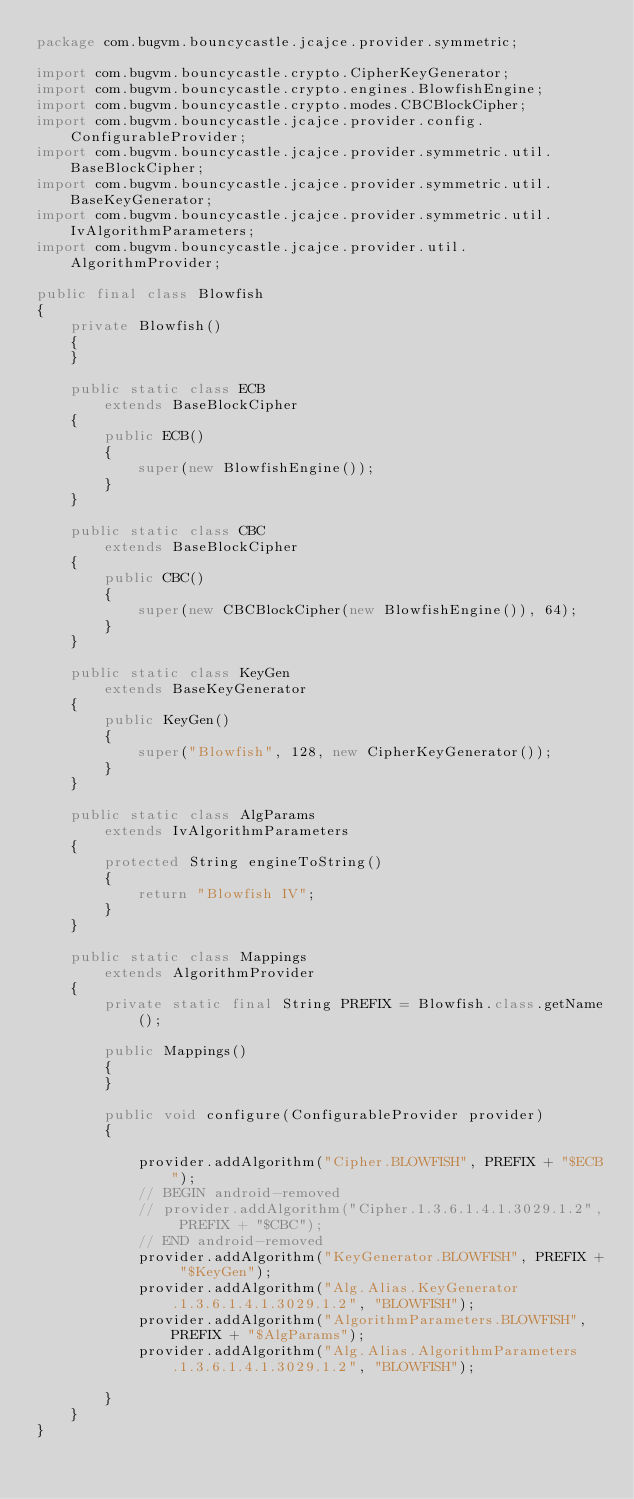Convert code to text. <code><loc_0><loc_0><loc_500><loc_500><_Java_>package com.bugvm.bouncycastle.jcajce.provider.symmetric;

import com.bugvm.bouncycastle.crypto.CipherKeyGenerator;
import com.bugvm.bouncycastle.crypto.engines.BlowfishEngine;
import com.bugvm.bouncycastle.crypto.modes.CBCBlockCipher;
import com.bugvm.bouncycastle.jcajce.provider.config.ConfigurableProvider;
import com.bugvm.bouncycastle.jcajce.provider.symmetric.util.BaseBlockCipher;
import com.bugvm.bouncycastle.jcajce.provider.symmetric.util.BaseKeyGenerator;
import com.bugvm.bouncycastle.jcajce.provider.symmetric.util.IvAlgorithmParameters;
import com.bugvm.bouncycastle.jcajce.provider.util.AlgorithmProvider;

public final class Blowfish
{
    private Blowfish()
    {
    }
    
    public static class ECB
        extends BaseBlockCipher
    {
        public ECB()
        {
            super(new BlowfishEngine());
        }
    }

    public static class CBC
        extends BaseBlockCipher
    {
        public CBC()
        {
            super(new CBCBlockCipher(new BlowfishEngine()), 64);
        }
    }

    public static class KeyGen
        extends BaseKeyGenerator
    {
        public KeyGen()
        {
            super("Blowfish", 128, new CipherKeyGenerator());
        }
    }

    public static class AlgParams
        extends IvAlgorithmParameters
    {
        protected String engineToString()
        {
            return "Blowfish IV";
        }
    }

    public static class Mappings
        extends AlgorithmProvider
    {
        private static final String PREFIX = Blowfish.class.getName();

        public Mappings()
        {
        }

        public void configure(ConfigurableProvider provider)
        {

            provider.addAlgorithm("Cipher.BLOWFISH", PREFIX + "$ECB");
            // BEGIN android-removed
            // provider.addAlgorithm("Cipher.1.3.6.1.4.1.3029.1.2", PREFIX + "$CBC");
            // END android-removed
            provider.addAlgorithm("KeyGenerator.BLOWFISH", PREFIX + "$KeyGen");
            provider.addAlgorithm("Alg.Alias.KeyGenerator.1.3.6.1.4.1.3029.1.2", "BLOWFISH");
            provider.addAlgorithm("AlgorithmParameters.BLOWFISH", PREFIX + "$AlgParams");
            provider.addAlgorithm("Alg.Alias.AlgorithmParameters.1.3.6.1.4.1.3029.1.2", "BLOWFISH");

        }
    }
}
</code> 